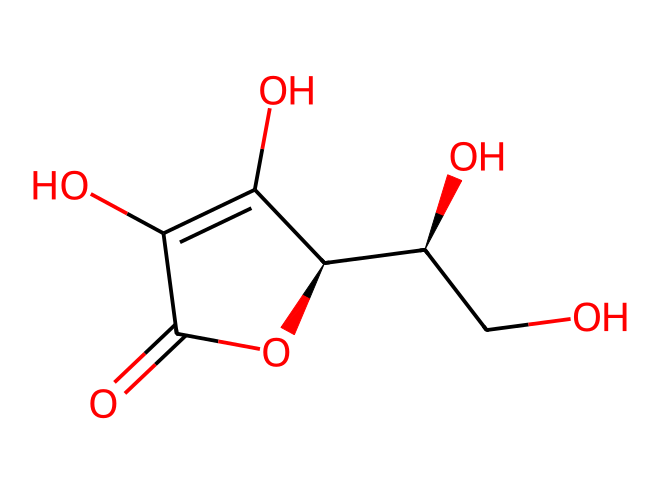What is the common name for the compound represented by the SMILES? The SMILES notation corresponds to the structure of ascorbic acid, which is widely known as Vitamin C.
Answer: Vitamin C How many carbon atoms are in the chemical structure? By counting the number of 'C' symbols present in the SMILES representation, we find there are 6 carbon atoms present.
Answer: 6 What type of functional group is prominently featured in Vitamin C? The compound contains multiple hydroxyl (-OH) groups, which are indicative of alcohol functionality in its structure.
Answer: hydroxyl What is the molecular formula for ascorbic acid? By determining the number of each type of atom present from the SMILES, we can deduce that the molecular formula is C6H8O6.
Answer: C6H8O6 What is a significant feature of Vitamin C related to its structure? Ascorbic acid has a lactone ring structure, which plays a crucial role in its antioxidant properties.
Answer: lactone ring What indicates that this compound is an antioxidant? The presence of hydroxyl groups bonded to the carbon atoms allows for electron donation, which characterizes it as an effective antioxidant.
Answer: hydroxyl groups 